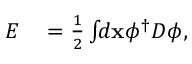Convert formula to latex. <formula><loc_0><loc_0><loc_500><loc_500>\begin{array} { r l } { E } & = \frac { 1 } { 2 } \int \, d x \phi ^ { \dagger } D \phi , } \end{array}</formula> 